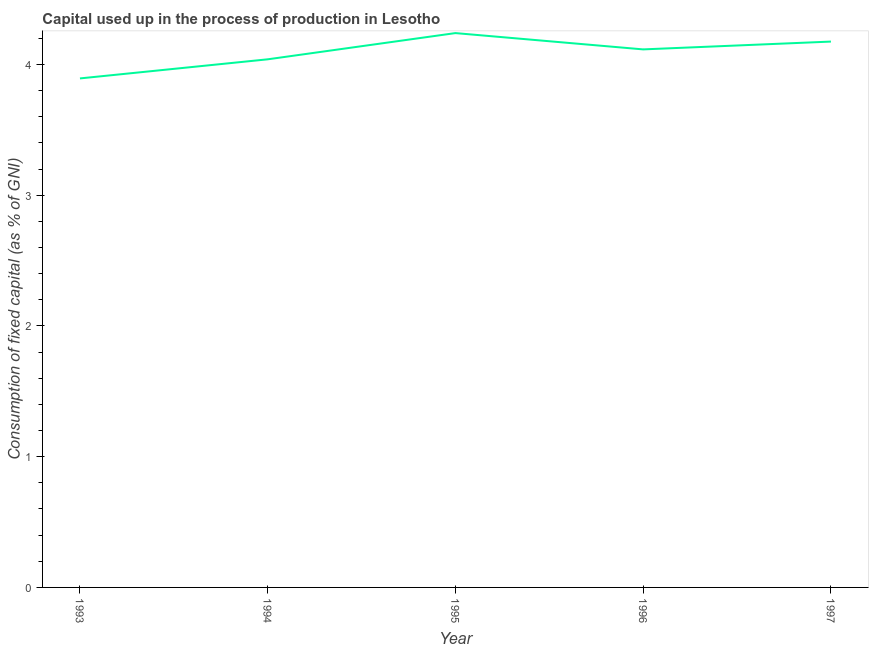What is the consumption of fixed capital in 1995?
Provide a short and direct response. 4.24. Across all years, what is the maximum consumption of fixed capital?
Provide a succinct answer. 4.24. Across all years, what is the minimum consumption of fixed capital?
Keep it short and to the point. 3.89. In which year was the consumption of fixed capital minimum?
Your response must be concise. 1993. What is the sum of the consumption of fixed capital?
Offer a terse response. 20.47. What is the difference between the consumption of fixed capital in 1993 and 1994?
Your answer should be compact. -0.15. What is the average consumption of fixed capital per year?
Provide a short and direct response. 4.09. What is the median consumption of fixed capital?
Offer a very short reply. 4.12. Do a majority of the years between 1994 and 1997 (inclusive) have consumption of fixed capital greater than 0.2 %?
Provide a succinct answer. Yes. What is the ratio of the consumption of fixed capital in 1993 to that in 1996?
Make the answer very short. 0.95. What is the difference between the highest and the second highest consumption of fixed capital?
Give a very brief answer. 0.06. Is the sum of the consumption of fixed capital in 1993 and 1996 greater than the maximum consumption of fixed capital across all years?
Your answer should be very brief. Yes. What is the difference between the highest and the lowest consumption of fixed capital?
Make the answer very short. 0.35. Does the consumption of fixed capital monotonically increase over the years?
Your answer should be very brief. No. Does the graph contain any zero values?
Offer a very short reply. No. What is the title of the graph?
Give a very brief answer. Capital used up in the process of production in Lesotho. What is the label or title of the Y-axis?
Make the answer very short. Consumption of fixed capital (as % of GNI). What is the Consumption of fixed capital (as % of GNI) of 1993?
Offer a terse response. 3.89. What is the Consumption of fixed capital (as % of GNI) in 1994?
Your response must be concise. 4.04. What is the Consumption of fixed capital (as % of GNI) in 1995?
Provide a succinct answer. 4.24. What is the Consumption of fixed capital (as % of GNI) in 1996?
Your response must be concise. 4.12. What is the Consumption of fixed capital (as % of GNI) in 1997?
Provide a succinct answer. 4.18. What is the difference between the Consumption of fixed capital (as % of GNI) in 1993 and 1994?
Your answer should be very brief. -0.15. What is the difference between the Consumption of fixed capital (as % of GNI) in 1993 and 1995?
Make the answer very short. -0.35. What is the difference between the Consumption of fixed capital (as % of GNI) in 1993 and 1996?
Your response must be concise. -0.22. What is the difference between the Consumption of fixed capital (as % of GNI) in 1993 and 1997?
Keep it short and to the point. -0.28. What is the difference between the Consumption of fixed capital (as % of GNI) in 1994 and 1995?
Provide a short and direct response. -0.2. What is the difference between the Consumption of fixed capital (as % of GNI) in 1994 and 1996?
Provide a short and direct response. -0.08. What is the difference between the Consumption of fixed capital (as % of GNI) in 1994 and 1997?
Offer a very short reply. -0.14. What is the difference between the Consumption of fixed capital (as % of GNI) in 1995 and 1996?
Your answer should be compact. 0.12. What is the difference between the Consumption of fixed capital (as % of GNI) in 1995 and 1997?
Provide a short and direct response. 0.06. What is the difference between the Consumption of fixed capital (as % of GNI) in 1996 and 1997?
Offer a terse response. -0.06. What is the ratio of the Consumption of fixed capital (as % of GNI) in 1993 to that in 1995?
Offer a very short reply. 0.92. What is the ratio of the Consumption of fixed capital (as % of GNI) in 1993 to that in 1996?
Give a very brief answer. 0.95. What is the ratio of the Consumption of fixed capital (as % of GNI) in 1993 to that in 1997?
Offer a terse response. 0.93. What is the ratio of the Consumption of fixed capital (as % of GNI) in 1994 to that in 1995?
Your answer should be compact. 0.95. What is the ratio of the Consumption of fixed capital (as % of GNI) in 1994 to that in 1996?
Your answer should be compact. 0.98. What is the ratio of the Consumption of fixed capital (as % of GNI) in 1994 to that in 1997?
Give a very brief answer. 0.97. What is the ratio of the Consumption of fixed capital (as % of GNI) in 1995 to that in 1996?
Your answer should be very brief. 1.03. What is the ratio of the Consumption of fixed capital (as % of GNI) in 1995 to that in 1997?
Offer a terse response. 1.02. 